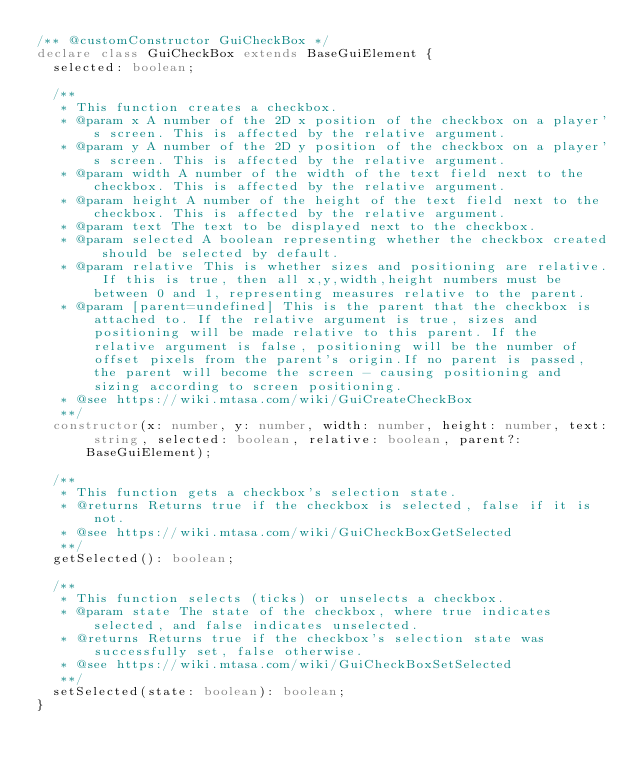<code> <loc_0><loc_0><loc_500><loc_500><_TypeScript_>/** @customConstructor GuiCheckBox */
declare class GuiCheckBox extends BaseGuiElement {
  selected: boolean;

  /**
   * This function creates a checkbox.
   * @param x A number of the 2D x position of the checkbox on a player's screen. This is affected by the relative argument.
   * @param y A number of the 2D y position of the checkbox on a player's screen. This is affected by the relative argument.
   * @param width A number of the width of the text field next to the checkbox. This is affected by the relative argument.
   * @param height A number of the height of the text field next to the checkbox. This is affected by the relative argument.
   * @param text The text to be displayed next to the checkbox.
   * @param selected A boolean representing whether the checkbox created should be selected by default.
   * @param relative This is whether sizes and positioning are relative. If this is true, then all x,y,width,height numbers must be between 0 and 1, representing measures relative to the parent.
   * @param [parent=undefined] This is the parent that the checkbox is attached to. If the relative argument is true, sizes and positioning will be made relative to this parent. If the relative argument is false, positioning will be the number of offset pixels from the parent's origin.If no parent is passed, the parent will become the screen - causing positioning and sizing according to screen positioning.
   * @see https://wiki.mtasa.com/wiki/GuiCreateCheckBox
   **/
  constructor(x: number, y: number, width: number, height: number, text: string, selected: boolean, relative: boolean, parent?: BaseGuiElement);

  /**
   * This function gets a checkbox's selection state.
   * @returns Returns true if the checkbox is selected, false if it is not.
   * @see https://wiki.mtasa.com/wiki/GuiCheckBoxGetSelected
   **/
  getSelected(): boolean;

  /**
   * This function selects (ticks) or unselects a checkbox.
   * @param state The state of the checkbox, where true indicates selected, and false indicates unselected.
   * @returns Returns true if the checkbox's selection state was successfully set, false otherwise.
   * @see https://wiki.mtasa.com/wiki/GuiCheckBoxSetSelected
   **/
  setSelected(state: boolean): boolean;
}
</code> 